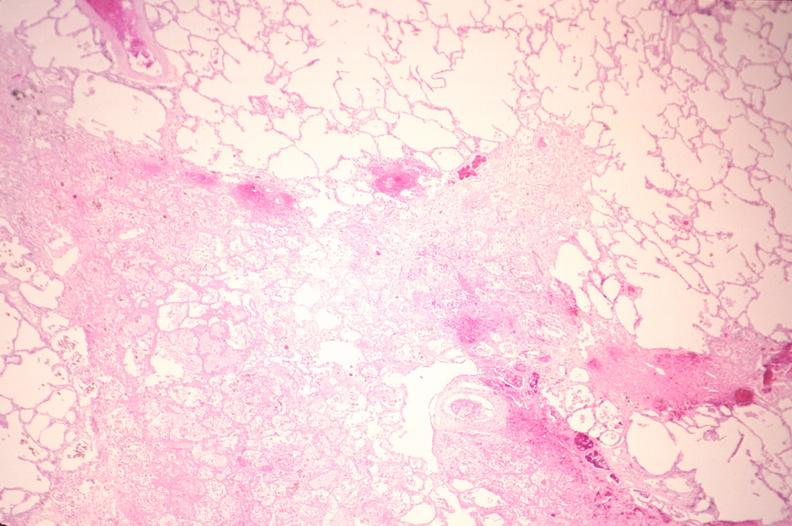s excellent vertebral body primary present?
Answer the question using a single word or phrase. No 